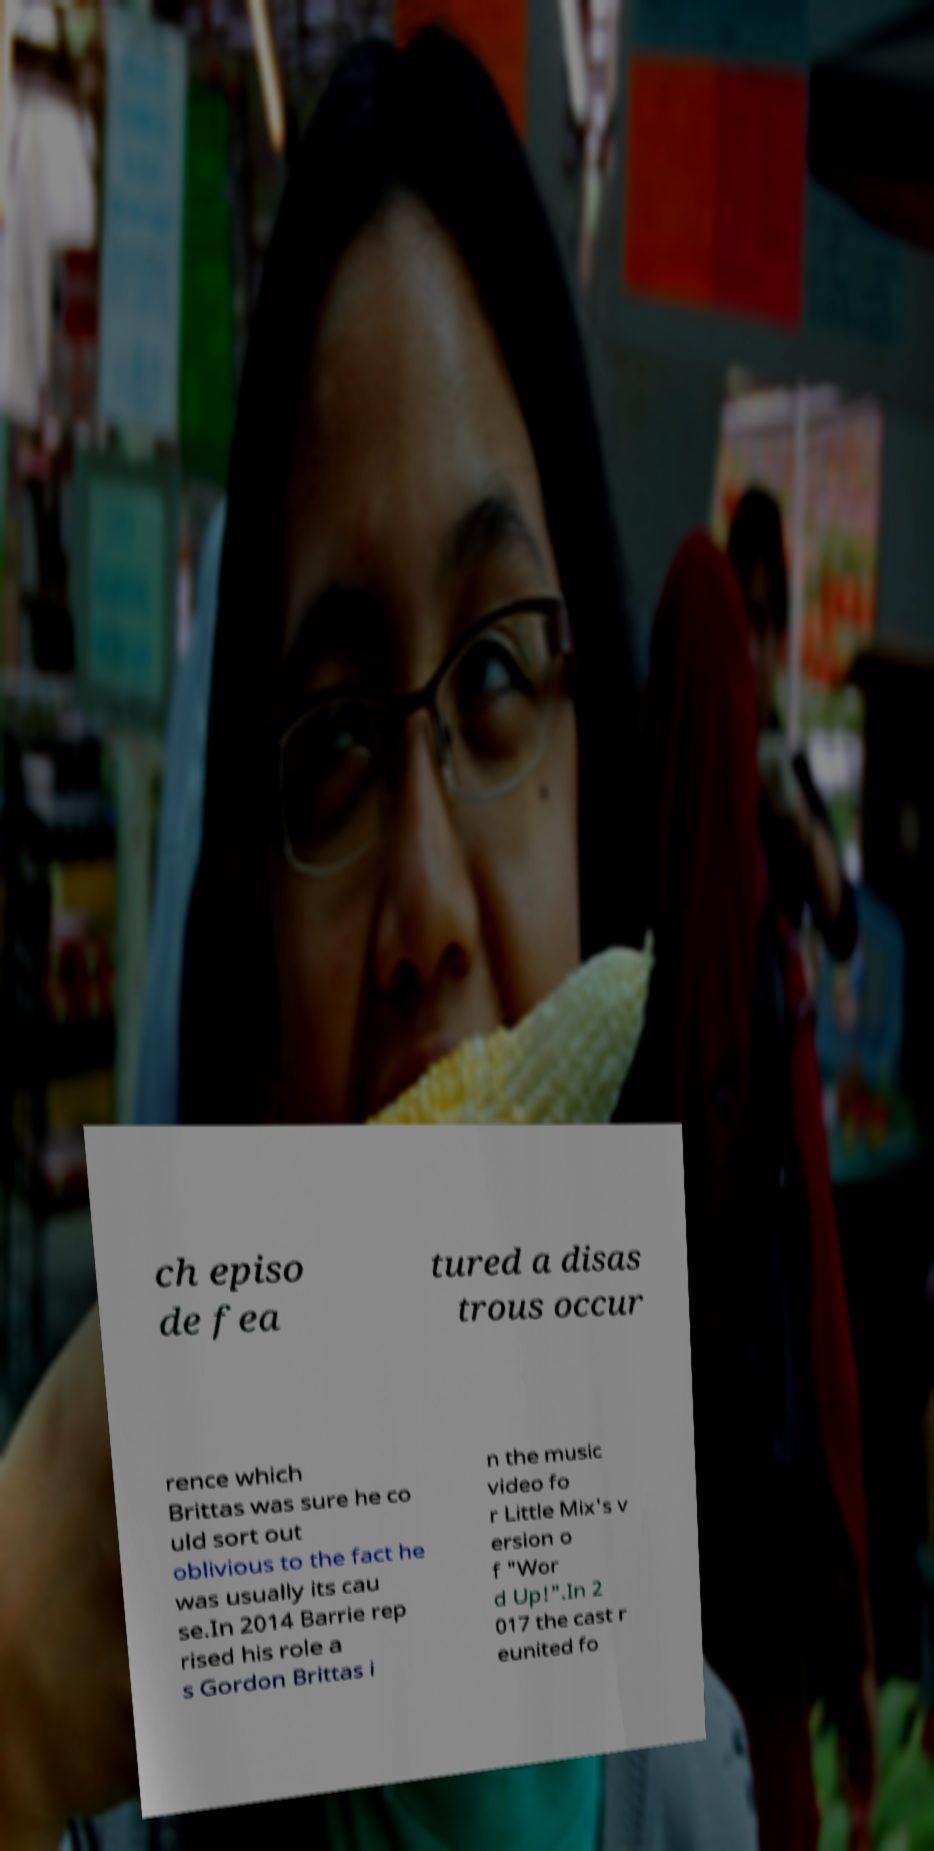I need the written content from this picture converted into text. Can you do that? ch episo de fea tured a disas trous occur rence which Brittas was sure he co uld sort out oblivious to the fact he was usually its cau se.In 2014 Barrie rep rised his role a s Gordon Brittas i n the music video fo r Little Mix's v ersion o f "Wor d Up!".In 2 017 the cast r eunited fo 